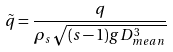<formula> <loc_0><loc_0><loc_500><loc_500>\tilde { q } = \frac { q } { \rho _ { s } \sqrt { ( s - 1 ) g D ^ { 3 } _ { m e a n } } }</formula> 